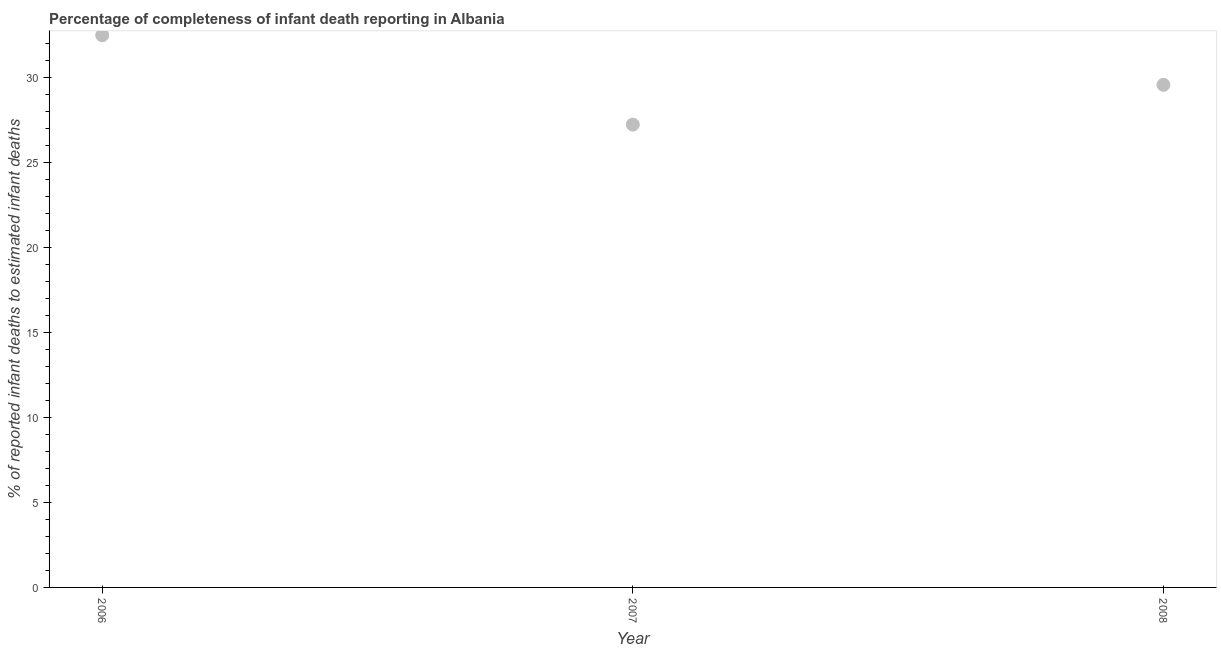What is the completeness of infant death reporting in 2008?
Your response must be concise. 29.56. Across all years, what is the maximum completeness of infant death reporting?
Your answer should be compact. 32.48. Across all years, what is the minimum completeness of infant death reporting?
Ensure brevity in your answer.  27.22. In which year was the completeness of infant death reporting maximum?
Offer a terse response. 2006. What is the sum of the completeness of infant death reporting?
Provide a succinct answer. 89.27. What is the difference between the completeness of infant death reporting in 2007 and 2008?
Keep it short and to the point. -2.34. What is the average completeness of infant death reporting per year?
Give a very brief answer. 29.76. What is the median completeness of infant death reporting?
Provide a succinct answer. 29.56. In how many years, is the completeness of infant death reporting greater than 9 %?
Give a very brief answer. 3. Do a majority of the years between 2007 and 2008 (inclusive) have completeness of infant death reporting greater than 18 %?
Your response must be concise. Yes. What is the ratio of the completeness of infant death reporting in 2006 to that in 2008?
Keep it short and to the point. 1.1. What is the difference between the highest and the second highest completeness of infant death reporting?
Your answer should be very brief. 2.91. Is the sum of the completeness of infant death reporting in 2006 and 2007 greater than the maximum completeness of infant death reporting across all years?
Ensure brevity in your answer.  Yes. What is the difference between the highest and the lowest completeness of infant death reporting?
Your answer should be very brief. 5.25. In how many years, is the completeness of infant death reporting greater than the average completeness of infant death reporting taken over all years?
Give a very brief answer. 1. Does the completeness of infant death reporting monotonically increase over the years?
Keep it short and to the point. No. Are the values on the major ticks of Y-axis written in scientific E-notation?
Ensure brevity in your answer.  No. What is the title of the graph?
Offer a terse response. Percentage of completeness of infant death reporting in Albania. What is the label or title of the X-axis?
Your response must be concise. Year. What is the label or title of the Y-axis?
Give a very brief answer. % of reported infant deaths to estimated infant deaths. What is the % of reported infant deaths to estimated infant deaths in 2006?
Ensure brevity in your answer.  32.48. What is the % of reported infant deaths to estimated infant deaths in 2007?
Offer a very short reply. 27.22. What is the % of reported infant deaths to estimated infant deaths in 2008?
Offer a very short reply. 29.56. What is the difference between the % of reported infant deaths to estimated infant deaths in 2006 and 2007?
Make the answer very short. 5.25. What is the difference between the % of reported infant deaths to estimated infant deaths in 2006 and 2008?
Provide a short and direct response. 2.91. What is the difference between the % of reported infant deaths to estimated infant deaths in 2007 and 2008?
Ensure brevity in your answer.  -2.34. What is the ratio of the % of reported infant deaths to estimated infant deaths in 2006 to that in 2007?
Provide a short and direct response. 1.19. What is the ratio of the % of reported infant deaths to estimated infant deaths in 2006 to that in 2008?
Your answer should be very brief. 1.1. What is the ratio of the % of reported infant deaths to estimated infant deaths in 2007 to that in 2008?
Offer a very short reply. 0.92. 